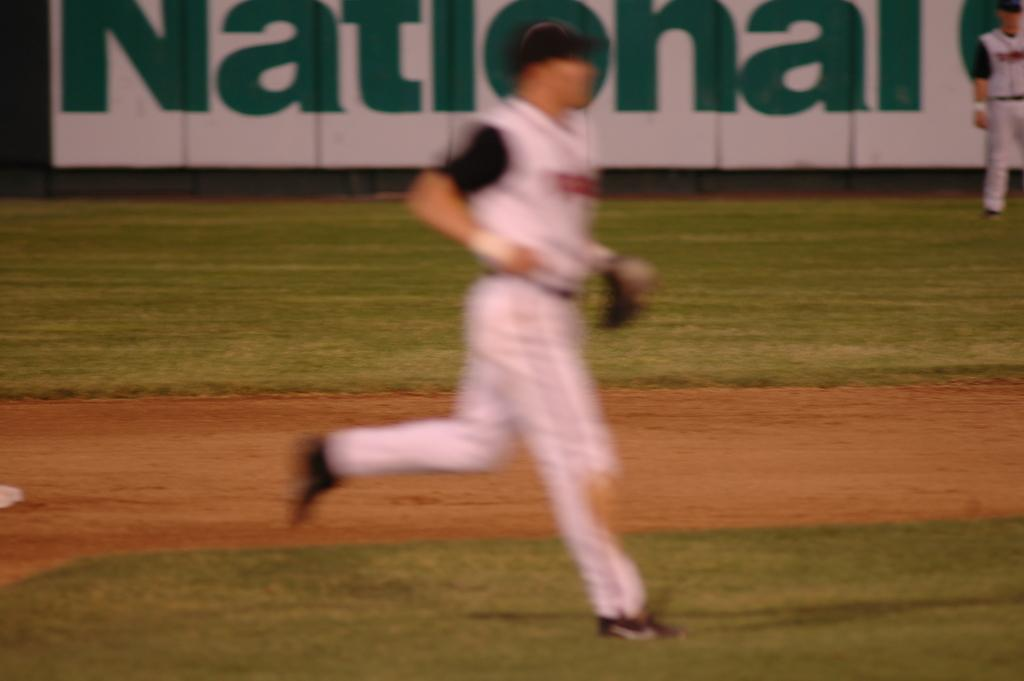<image>
Share a concise interpretation of the image provided. A baseball player is running but out of focus for the camera with an ad for national in the background. 